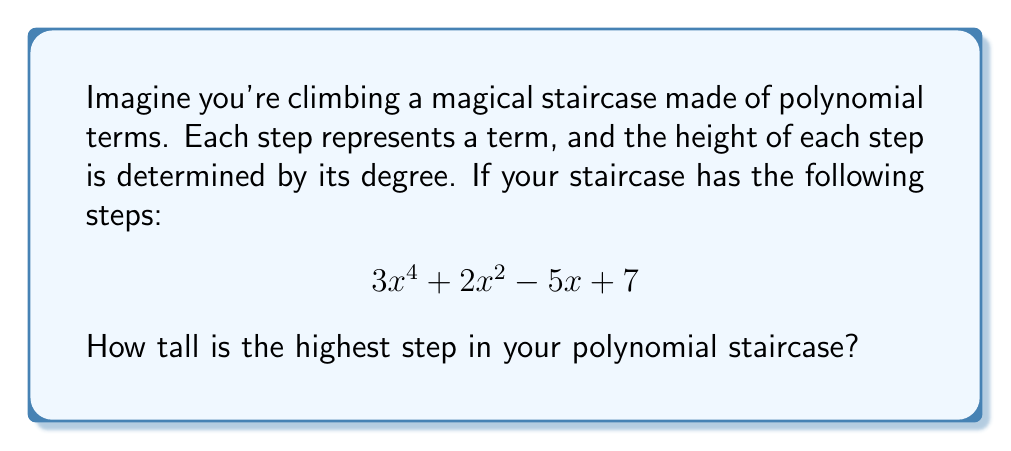Give your solution to this math problem. Let's climb this polynomial staircase together!

1. First, let's identify each step (term) in our polynomial:
   - Step 1: $3x^4$
   - Step 2: $2x^2$
   - Step 3: $-5x$
   - Step 4: $7$

2. Now, let's look at the height (degree) of each step:
   - $3x^4$ has a degree of 4
   - $2x^2$ has a degree of 2
   - $-5x$ has a degree of 1
   - $7$ has a degree of 0 (constants have no $x$, so their degree is 0)

3. The tallest step will be the one with the highest degree. In this case, it's the first step, $3x^4$, with a degree of 4.

4. Remember, the degree of a polynomial is always the highest power of $x$ in any of its terms.

So, the highest step in our polynomial staircase is 4 steps tall!
Answer: 4 